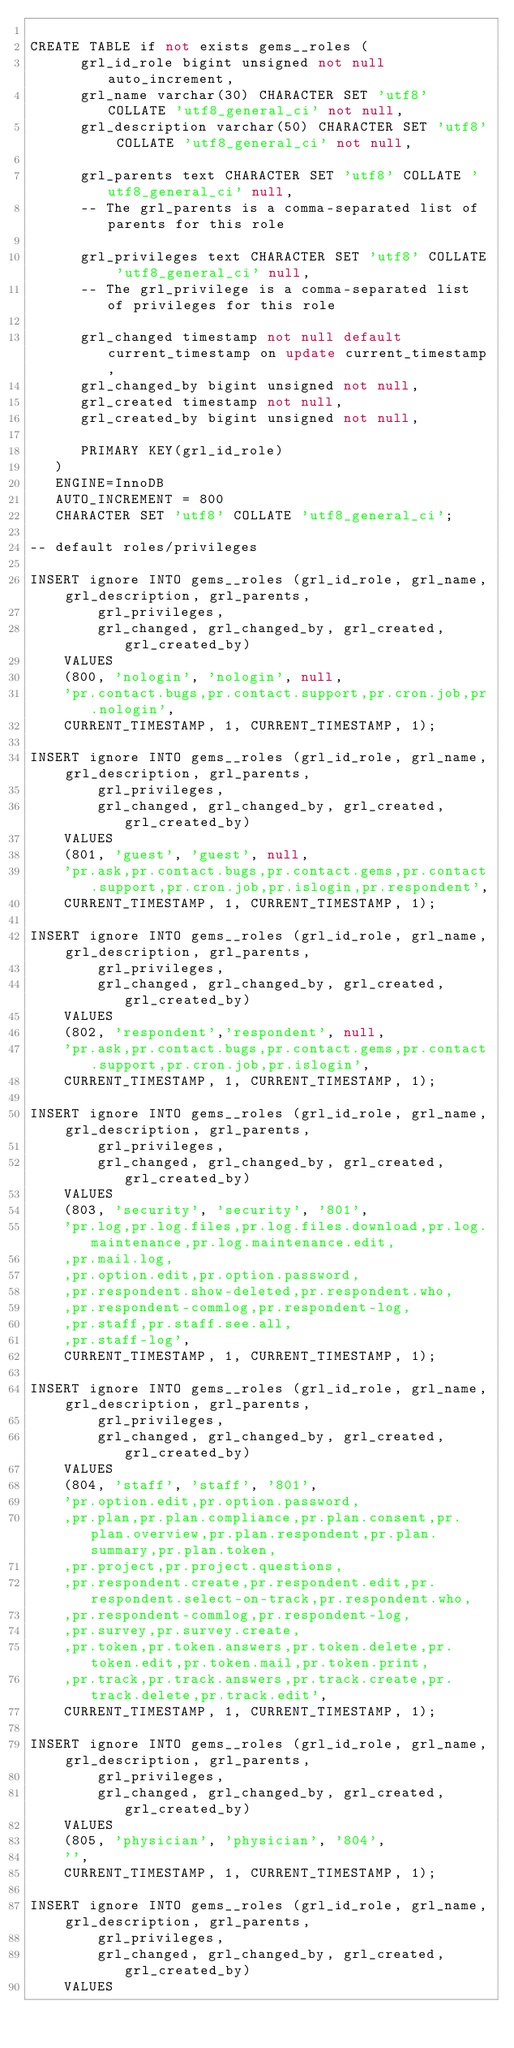<code> <loc_0><loc_0><loc_500><loc_500><_SQL_>
CREATE TABLE if not exists gems__roles (
      grl_id_role bigint unsigned not null auto_increment,
      grl_name varchar(30) CHARACTER SET 'utf8' COLLATE 'utf8_general_ci' not null,
      grl_description varchar(50) CHARACTER SET 'utf8' COLLATE 'utf8_general_ci' not null,

      grl_parents text CHARACTER SET 'utf8' COLLATE 'utf8_general_ci' null,
      -- The grl_parents is a comma-separated list of parents for this role

      grl_privileges text CHARACTER SET 'utf8' COLLATE 'utf8_general_ci' null,
      -- The grl_privilege is a comma-separated list of privileges for this role

      grl_changed timestamp not null default current_timestamp on update current_timestamp,
      grl_changed_by bigint unsigned not null,
      grl_created timestamp not null,
      grl_created_by bigint unsigned not null,

      PRIMARY KEY(grl_id_role)
   )
   ENGINE=InnoDB
   AUTO_INCREMENT = 800
   CHARACTER SET 'utf8' COLLATE 'utf8_general_ci';

-- default roles/privileges

INSERT ignore INTO gems__roles (grl_id_role, grl_name, grl_description, grl_parents,
        grl_privileges,
        grl_changed, grl_changed_by, grl_created, grl_created_by)
    VALUES
    (800, 'nologin', 'nologin', null,
    'pr.contact.bugs,pr.contact.support,pr.cron.job,pr.nologin',
    CURRENT_TIMESTAMP, 1, CURRENT_TIMESTAMP, 1);

INSERT ignore INTO gems__roles (grl_id_role, grl_name, grl_description, grl_parents,
        grl_privileges,
        grl_changed, grl_changed_by, grl_created, grl_created_by)
    VALUES
    (801, 'guest', 'guest', null,
    'pr.ask,pr.contact.bugs,pr.contact.gems,pr.contact.support,pr.cron.job,pr.islogin,pr.respondent',
    CURRENT_TIMESTAMP, 1, CURRENT_TIMESTAMP, 1);

INSERT ignore INTO gems__roles (grl_id_role, grl_name, grl_description, grl_parents,
        grl_privileges,
        grl_changed, grl_changed_by, grl_created, grl_created_by)
    VALUES
    (802, 'respondent','respondent', null,
    'pr.ask,pr.contact.bugs,pr.contact.gems,pr.contact.support,pr.cron.job,pr.islogin',
    CURRENT_TIMESTAMP, 1, CURRENT_TIMESTAMP, 1);

INSERT ignore INTO gems__roles (grl_id_role, grl_name, grl_description, grl_parents,
        grl_privileges,
        grl_changed, grl_changed_by, grl_created, grl_created_by)
    VALUES
    (803, 'security', 'security', '801',
    'pr.log,pr.log.files,pr.log.files.download,pr.log.maintenance,pr.log.maintenance.edit,
    ,pr.mail.log,
    ,pr.option.edit,pr.option.password,
    ,pr.respondent.show-deleted,pr.respondent.who,
    ,pr.respondent-commlog,pr.respondent-log,
    ,pr.staff,pr.staff.see.all,
    ,pr.staff-log',
    CURRENT_TIMESTAMP, 1, CURRENT_TIMESTAMP, 1);

INSERT ignore INTO gems__roles (grl_id_role, grl_name, grl_description, grl_parents,
        grl_privileges,
        grl_changed, grl_changed_by, grl_created, grl_created_by)
    VALUES
    (804, 'staff', 'staff', '801',
    'pr.option.edit,pr.option.password,
    ,pr.plan,pr.plan.compliance,pr.plan.consent,pr.plan.overview,pr.plan.respondent,pr.plan.summary,pr.plan.token,
    ,pr.project,pr.project.questions,
    ,pr.respondent.create,pr.respondent.edit,pr.respondent.select-on-track,pr.respondent.who,
    ,pr.respondent-commlog,pr.respondent-log,
    ,pr.survey,pr.survey.create,
    ,pr.token,pr.token.answers,pr.token.delete,pr.token.edit,pr.token.mail,pr.token.print,
    ,pr.track,pr.track.answers,pr.track.create,pr.track.delete,pr.track.edit',
    CURRENT_TIMESTAMP, 1, CURRENT_TIMESTAMP, 1);

INSERT ignore INTO gems__roles (grl_id_role, grl_name, grl_description, grl_parents,
        grl_privileges,
        grl_changed, grl_changed_by, grl_created, grl_created_by)
    VALUES
    (805, 'physician', 'physician', '804',
    '',
    CURRENT_TIMESTAMP, 1, CURRENT_TIMESTAMP, 1);

INSERT ignore INTO gems__roles (grl_id_role, grl_name, grl_description, grl_parents,
        grl_privileges,
        grl_changed, grl_changed_by, grl_created, grl_created_by)
    VALUES</code> 